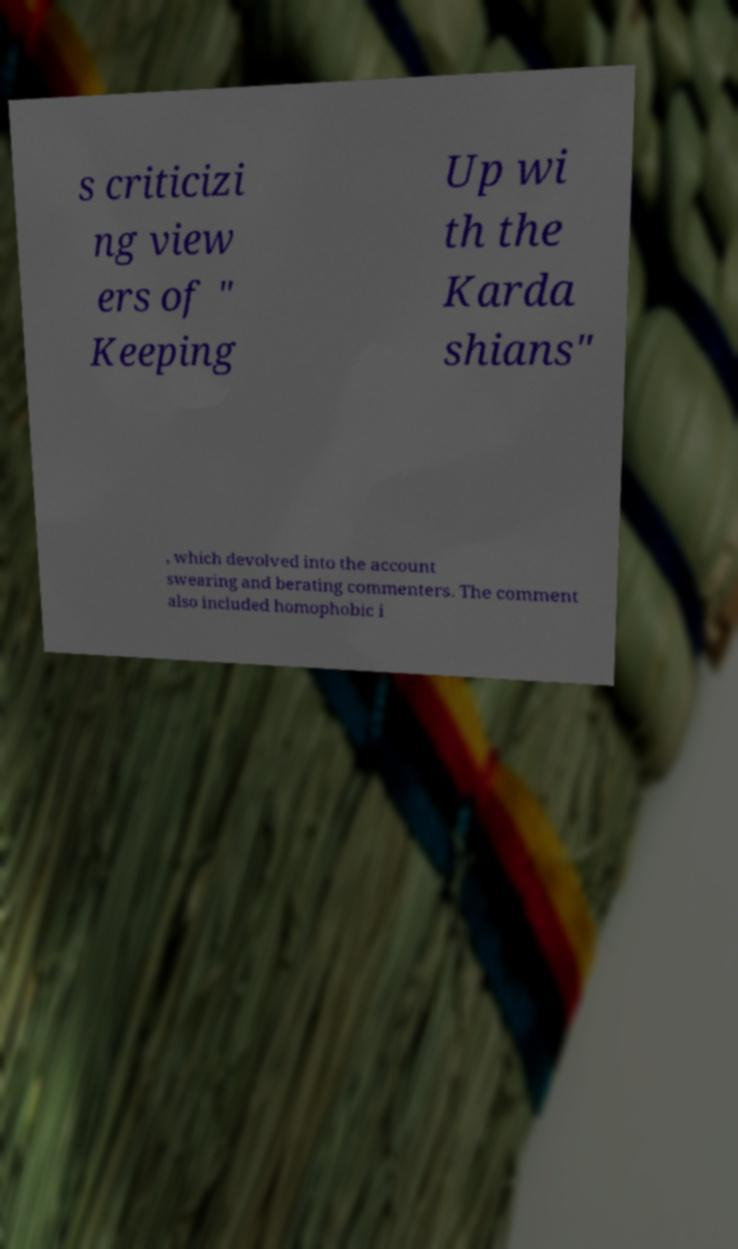Please identify and transcribe the text found in this image. s criticizi ng view ers of " Keeping Up wi th the Karda shians" , which devolved into the account swearing and berating commenters. The comment also included homophobic i 